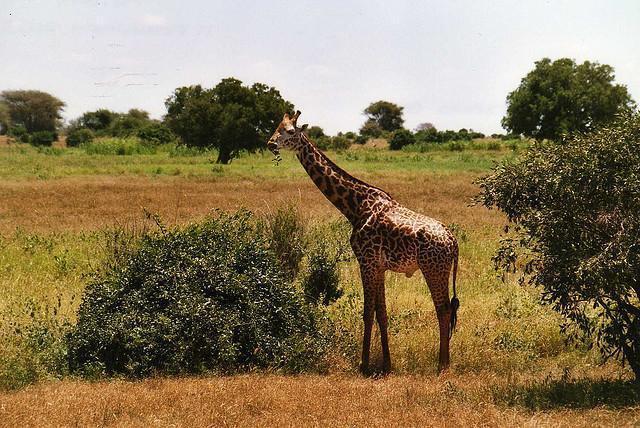How many sets of train tracks do you see?
Give a very brief answer. 0. 